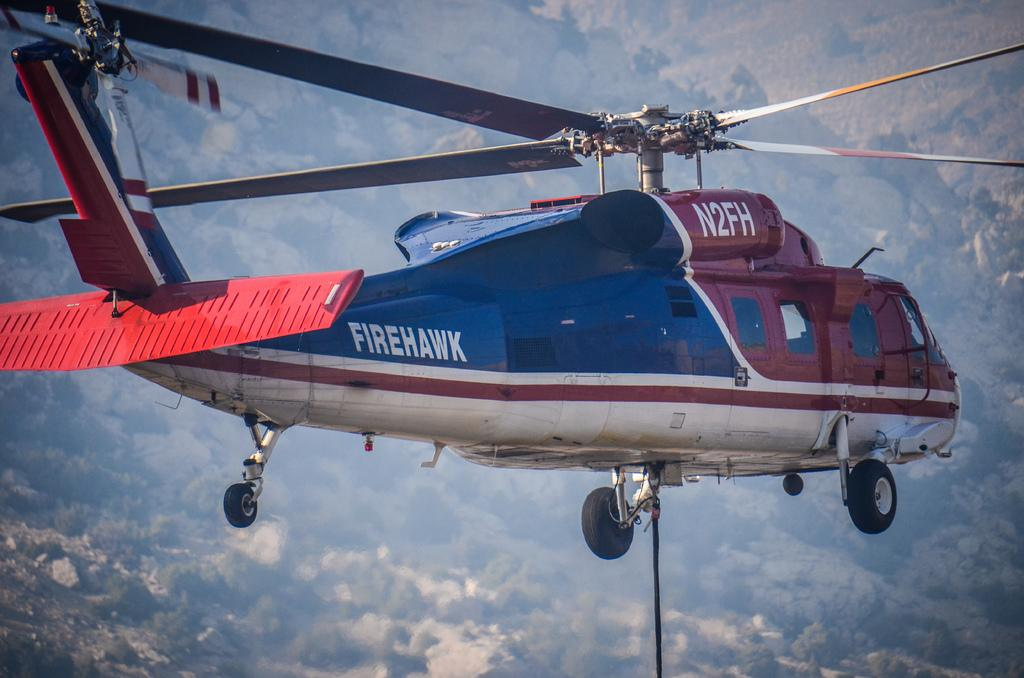<image>
Write a terse but informative summary of the picture. A chopper with a name "firehawk" hovers with its rope lowered down. 